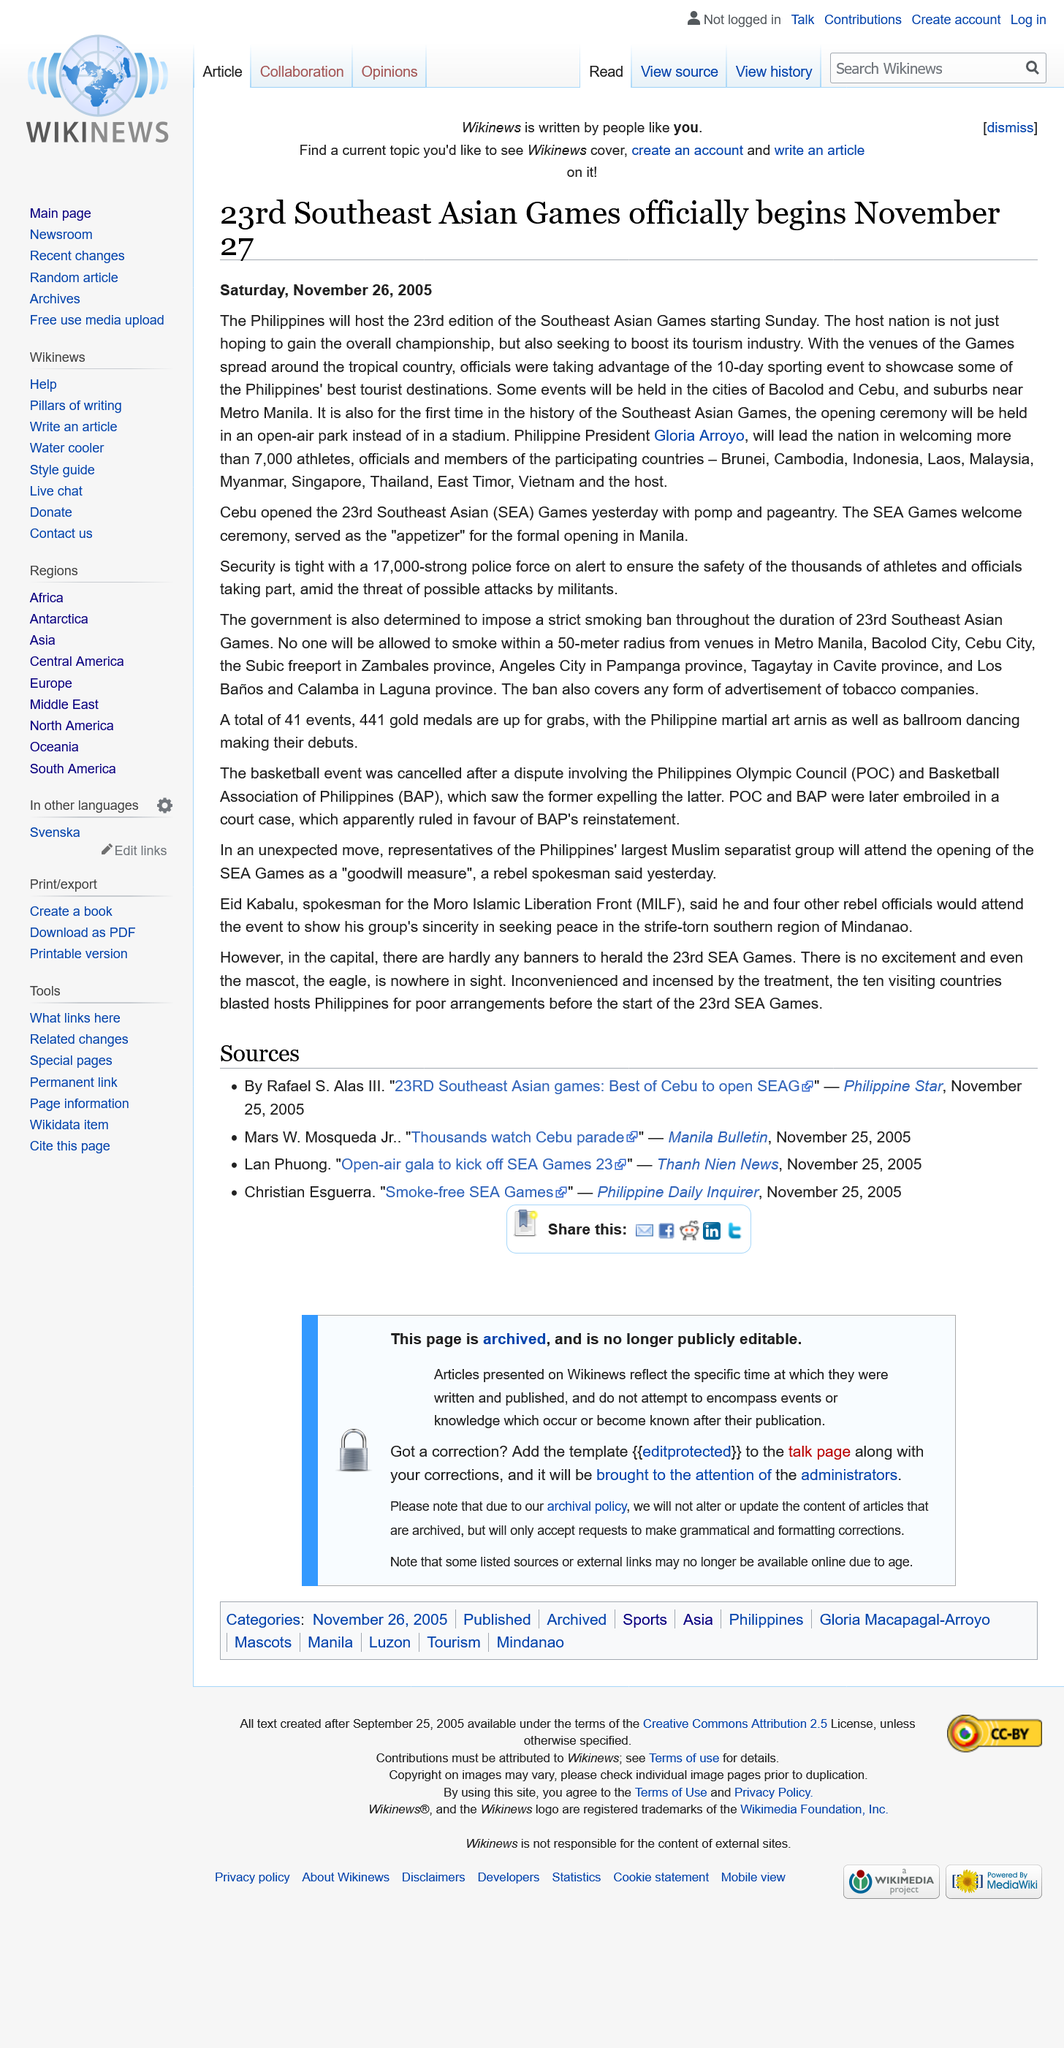Highlight a few significant elements in this photo. The 23rd Southeast Asian Games will commence on November 27, 2015. Ms. Gloria Arroyo is the current President of the Philippines. The games are participated in by various countries, including Brunei, Cambodia, Indonesia, Laos, Malaysia, Myanmar, Singapore, Thailand, East Timor, Vietnam, and the Philippines. 